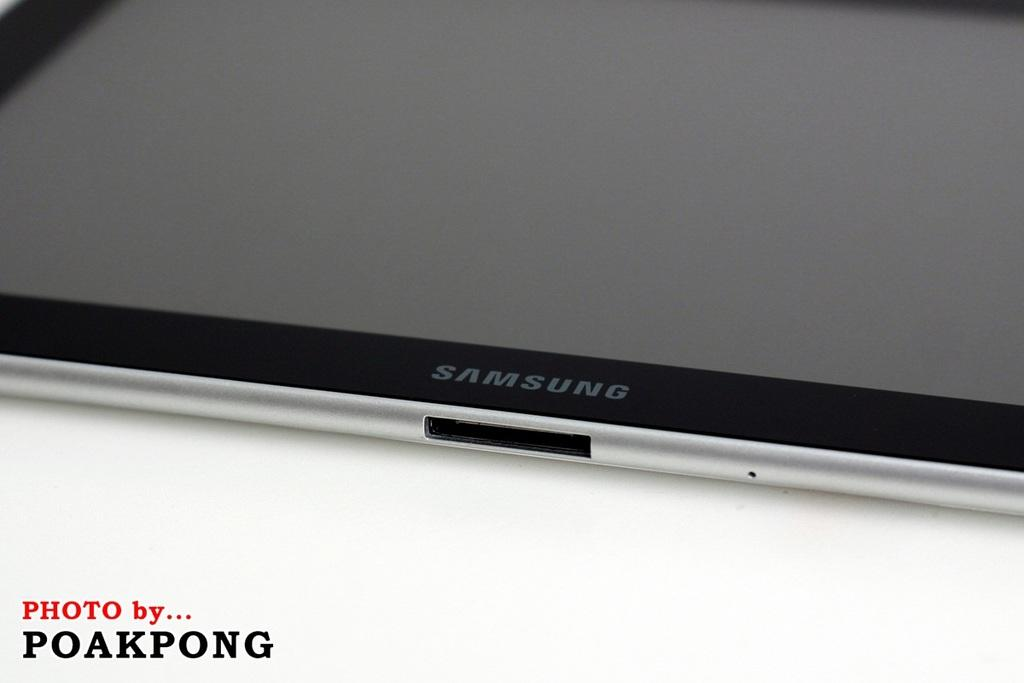<image>
Create a compact narrative representing the image presented. Silver and black Samsung tablet taken by Poakpong 